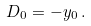<formula> <loc_0><loc_0><loc_500><loc_500>D _ { 0 } = - y _ { 0 } \, .</formula> 